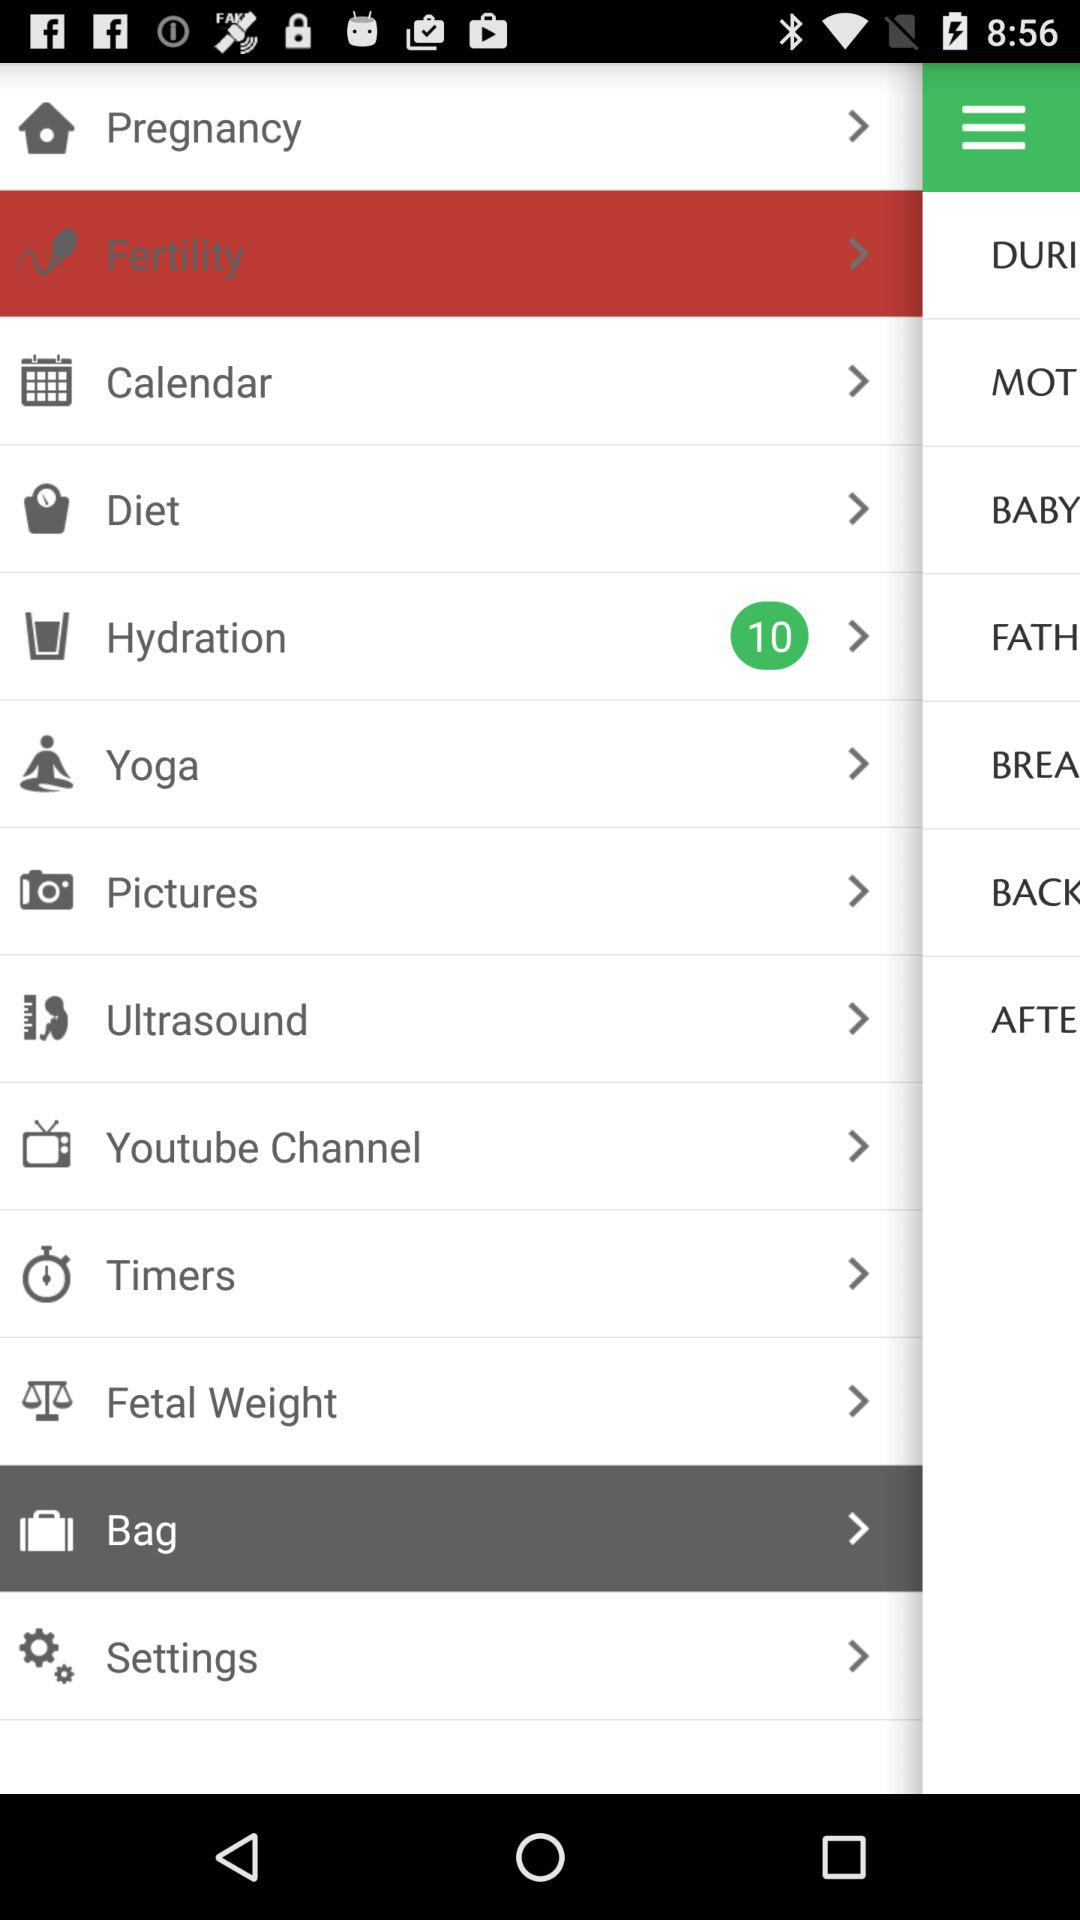What is the count mentioned for "Hydration"? The count mentioned for "Hydration" is 10. 